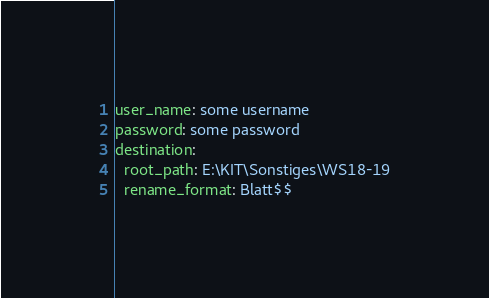<code> <loc_0><loc_0><loc_500><loc_500><_YAML_>user_name: some username
password: some password
destination:
  root_path: E:\KIT\Sonstiges\WS18-19
  rename_format: Blatt$$
</code> 